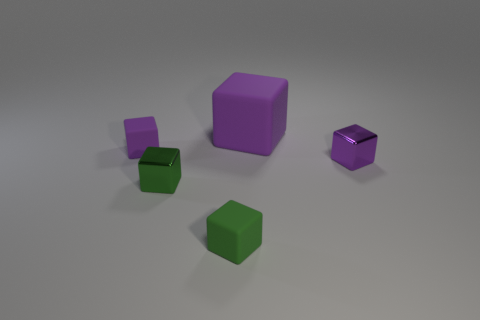How many purple blocks must be subtracted to get 1 purple blocks? 2 Subtract all red cylinders. How many purple blocks are left? 3 Subtract 1 blocks. How many blocks are left? 4 Subtract all small purple metal blocks. How many blocks are left? 4 Subtract all blue blocks. Subtract all red cylinders. How many blocks are left? 5 Add 3 blue blocks. How many objects exist? 8 Subtract 0 gray cylinders. How many objects are left? 5 Subtract all small metal objects. Subtract all purple metallic blocks. How many objects are left? 2 Add 1 small green metal objects. How many small green metal objects are left? 2 Add 4 green matte blocks. How many green matte blocks exist? 5 